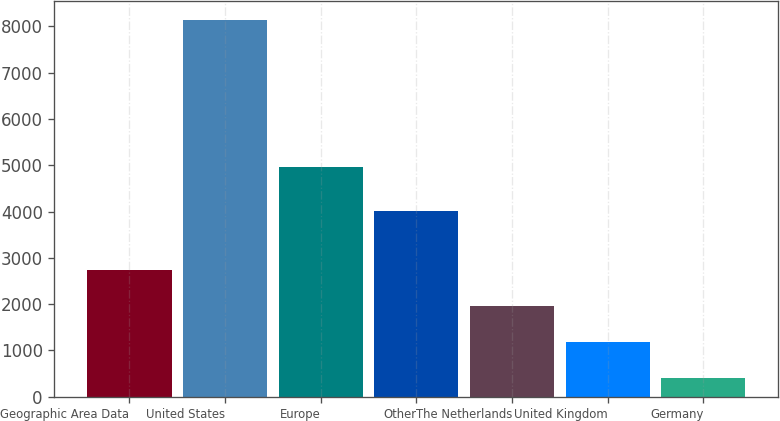<chart> <loc_0><loc_0><loc_500><loc_500><bar_chart><fcel>Geographic Area Data<fcel>United States<fcel>Europe<fcel>Other<fcel>The Netherlands<fcel>United Kingdom<fcel>Germany<nl><fcel>2727.15<fcel>8147.6<fcel>4967.2<fcel>4009<fcel>1952.8<fcel>1178.45<fcel>404.1<nl></chart> 